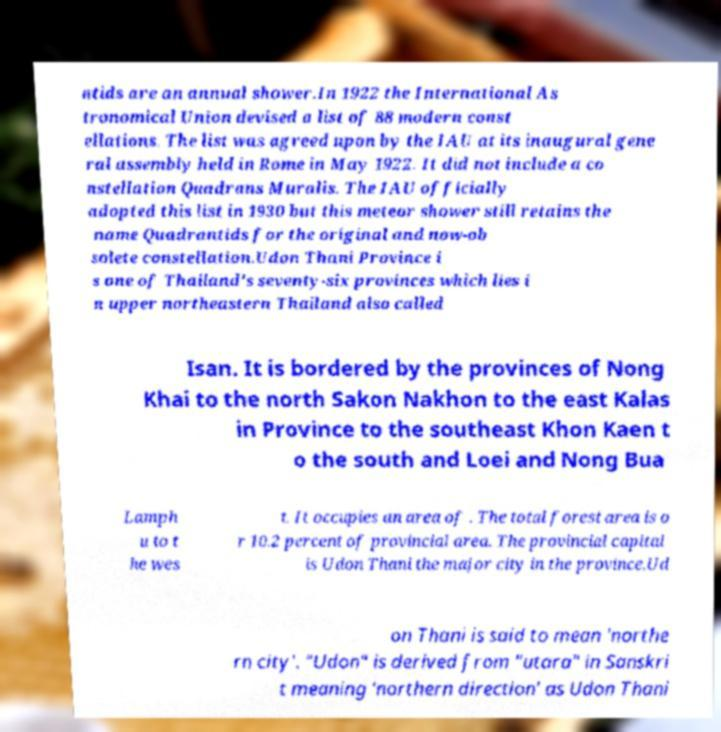Please identify and transcribe the text found in this image. ntids are an annual shower.In 1922 the International As tronomical Union devised a list of 88 modern const ellations. The list was agreed upon by the IAU at its inaugural gene ral assembly held in Rome in May 1922. It did not include a co nstellation Quadrans Muralis. The IAU officially adopted this list in 1930 but this meteor shower still retains the name Quadrantids for the original and now-ob solete constellation.Udon Thani Province i s one of Thailand's seventy-six provinces which lies i n upper northeastern Thailand also called Isan. It is bordered by the provinces of Nong Khai to the north Sakon Nakhon to the east Kalas in Province to the southeast Khon Kaen t o the south and Loei and Nong Bua Lamph u to t he wes t. It occupies an area of . The total forest area is o r 10.2 percent of provincial area. The provincial capital is Udon Thani the major city in the province.Ud on Thani is said to mean 'northe rn city'. "Udon" is derived from "utara" in Sanskri t meaning 'northern direction' as Udon Thani 